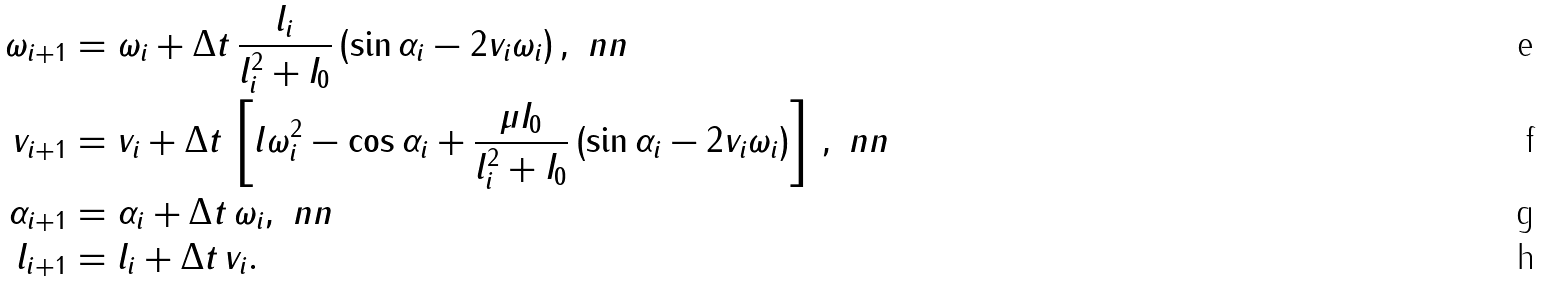<formula> <loc_0><loc_0><loc_500><loc_500>\omega _ { i + 1 } & = \omega _ { i } + \Delta t \, \frac { l _ { i } } { l _ { i } ^ { 2 } + I _ { 0 } } \left ( \sin \alpha _ { i } - 2 v _ { i } \omega _ { i } \right ) , \ n n \\ v _ { i + 1 } & = v _ { i } + \Delta t \, \left [ l \omega _ { i } ^ { 2 } - \cos \alpha _ { i } + \frac { \mu I _ { 0 } } { l _ { i } ^ { 2 } + I _ { 0 } } \left ( \sin \alpha _ { i } - 2 v _ { i } \omega _ { i } \right ) \right ] \, , \ n n \\ \alpha _ { i + 1 } & = \alpha _ { i } + \Delta t \, \omega _ { i } , \ n n \\ l _ { i + 1 } & = l _ { i } + \Delta t \, v _ { i } .</formula> 